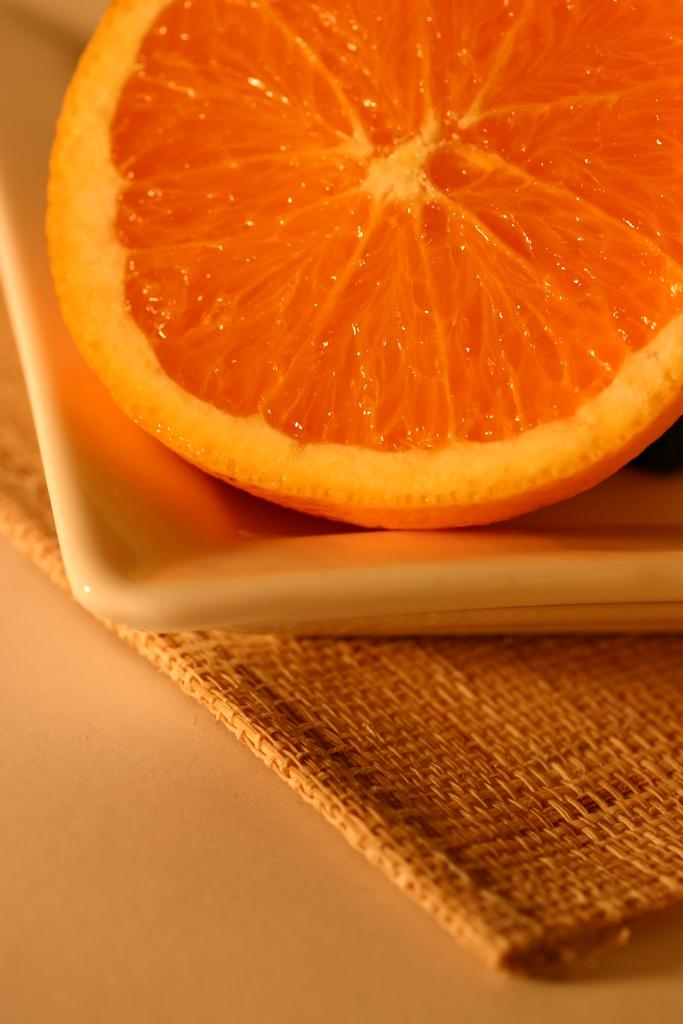What type of fruit is visible in the image? There is an orange slice in the image. Where is the orange slice located? The orange slice is present on a bowl. What is on the surface beneath the bowl in the image? There is a mat on the surface in the image. What direction is the orange slice facing in the image? The direction the orange slice is facing cannot be determined from the image, as it is a static object. 